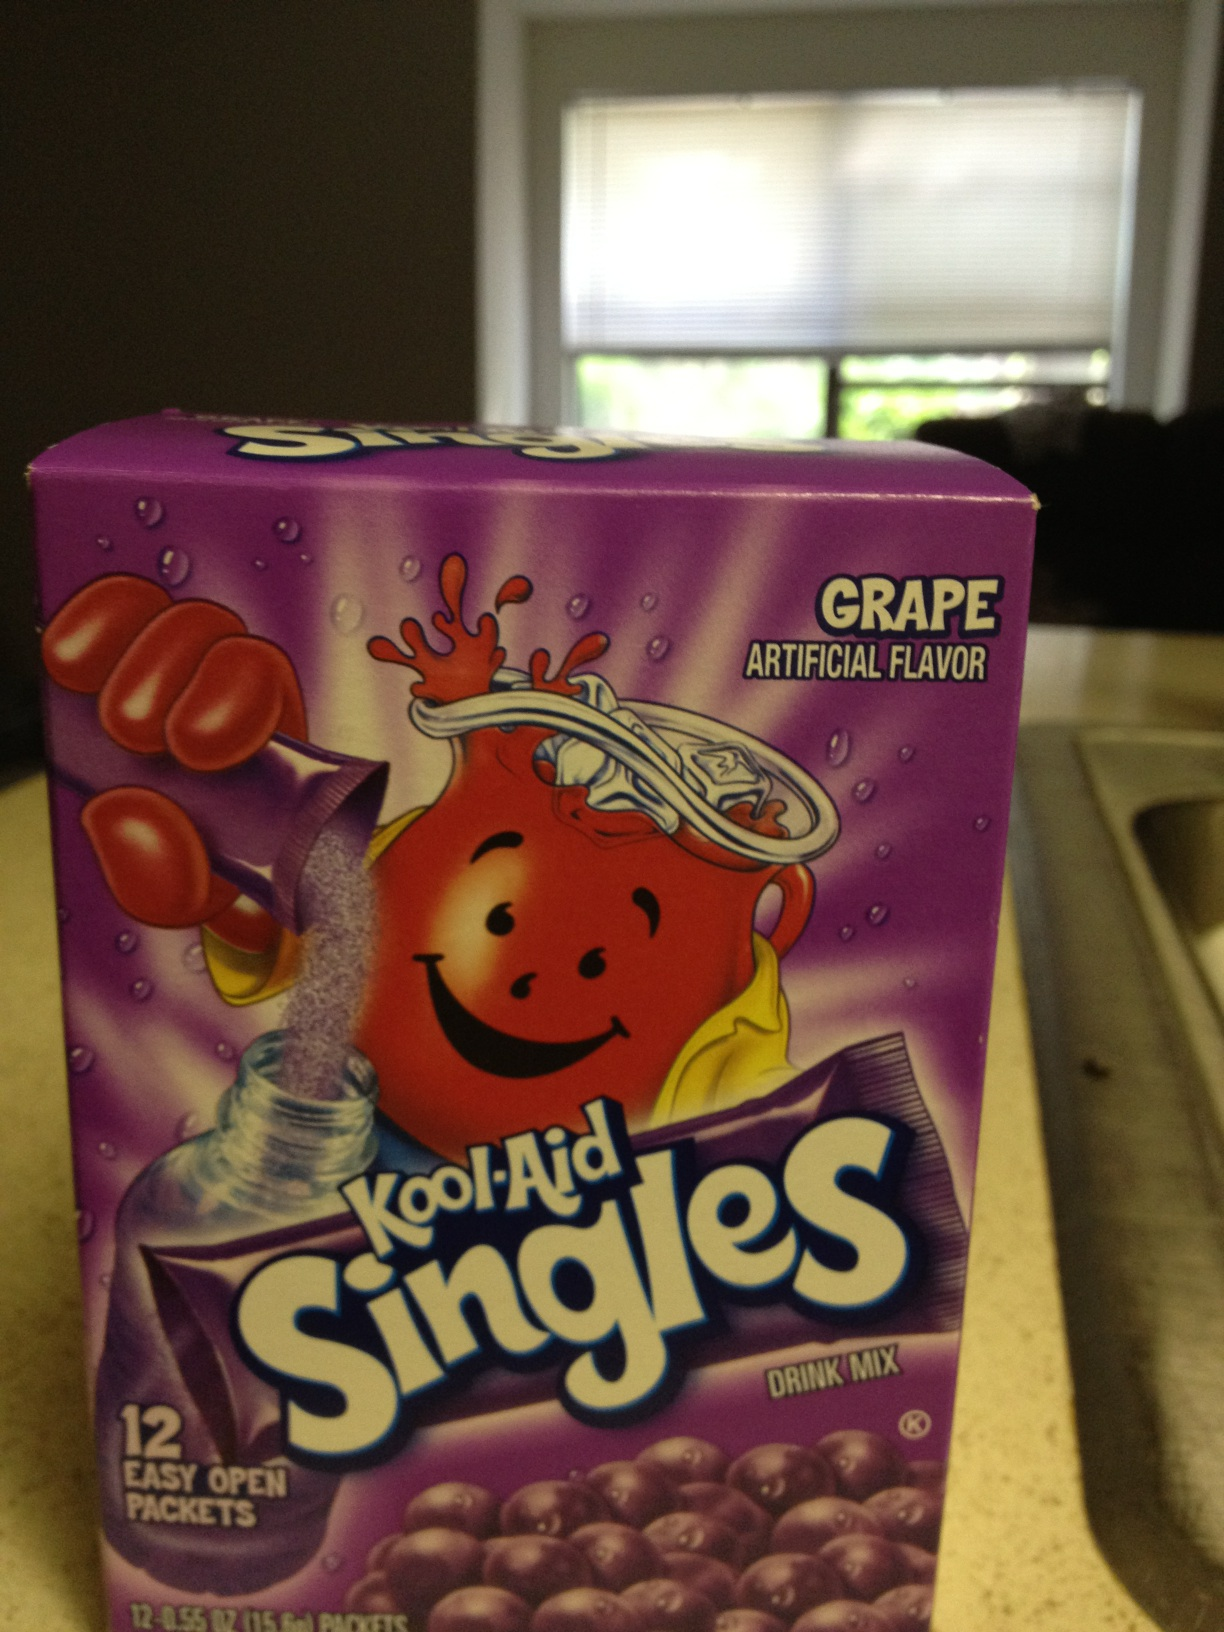What is this? This is a box of Kool-Aid Singles in grape flavor. It contains 12 easy-open packets of drink mix, designed for single servings. 